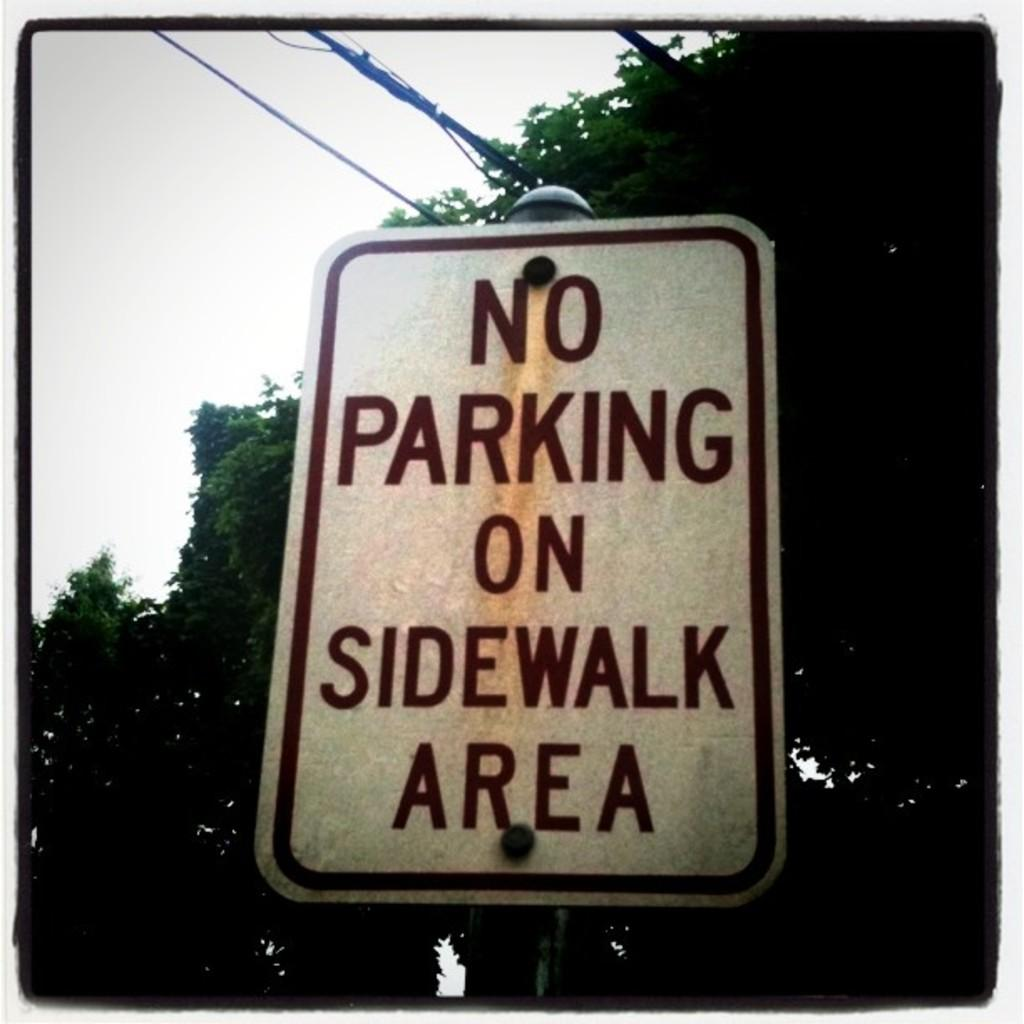Provide a one-sentence caption for the provided image. A sign stating there is no parking on the sidewalk area. 